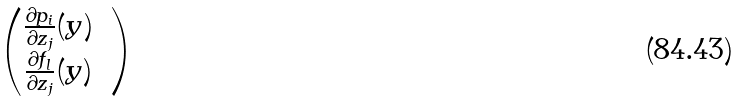Convert formula to latex. <formula><loc_0><loc_0><loc_500><loc_500>\begin{pmatrix} \frac { \partial p _ { i } } { \partial z _ { j } } ( y ) & \\ \frac { \partial f _ { l } } { \partial z _ { j } } ( y ) & \\ \end{pmatrix}</formula> 